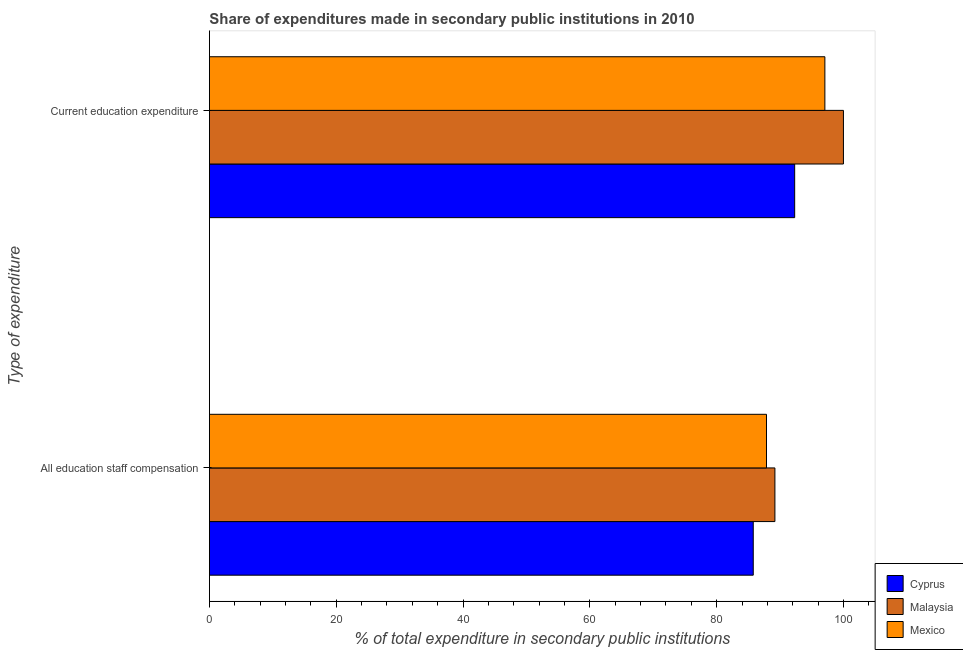Are the number of bars per tick equal to the number of legend labels?
Offer a terse response. Yes. Are the number of bars on each tick of the Y-axis equal?
Offer a very short reply. Yes. How many bars are there on the 1st tick from the top?
Ensure brevity in your answer.  3. What is the label of the 2nd group of bars from the top?
Provide a short and direct response. All education staff compensation. What is the expenditure in staff compensation in Malaysia?
Ensure brevity in your answer.  89.18. Across all countries, what is the maximum expenditure in education?
Make the answer very short. 99.99. Across all countries, what is the minimum expenditure in staff compensation?
Make the answer very short. 85.76. In which country was the expenditure in education maximum?
Offer a very short reply. Malaysia. In which country was the expenditure in education minimum?
Your answer should be very brief. Cyprus. What is the total expenditure in staff compensation in the graph?
Provide a succinct answer. 262.8. What is the difference between the expenditure in education in Cyprus and that in Malaysia?
Your response must be concise. -7.69. What is the difference between the expenditure in education in Cyprus and the expenditure in staff compensation in Mexico?
Offer a very short reply. 4.44. What is the average expenditure in education per country?
Give a very brief answer. 96.45. What is the difference between the expenditure in education and expenditure in staff compensation in Mexico?
Your response must be concise. 9.21. In how many countries, is the expenditure in staff compensation greater than 56 %?
Your response must be concise. 3. What is the ratio of the expenditure in education in Malaysia to that in Mexico?
Your answer should be compact. 1.03. In how many countries, is the expenditure in staff compensation greater than the average expenditure in staff compensation taken over all countries?
Your answer should be compact. 2. What does the 2nd bar from the top in All education staff compensation represents?
Make the answer very short. Malaysia. How many countries are there in the graph?
Your response must be concise. 3. Does the graph contain any zero values?
Your response must be concise. No. Where does the legend appear in the graph?
Offer a terse response. Bottom right. How many legend labels are there?
Your response must be concise. 3. What is the title of the graph?
Your response must be concise. Share of expenditures made in secondary public institutions in 2010. What is the label or title of the X-axis?
Ensure brevity in your answer.  % of total expenditure in secondary public institutions. What is the label or title of the Y-axis?
Your response must be concise. Type of expenditure. What is the % of total expenditure in secondary public institutions in Cyprus in All education staff compensation?
Offer a very short reply. 85.76. What is the % of total expenditure in secondary public institutions in Malaysia in All education staff compensation?
Make the answer very short. 89.18. What is the % of total expenditure in secondary public institutions of Mexico in All education staff compensation?
Give a very brief answer. 87.85. What is the % of total expenditure in secondary public institutions of Cyprus in Current education expenditure?
Make the answer very short. 92.3. What is the % of total expenditure in secondary public institutions in Malaysia in Current education expenditure?
Your response must be concise. 99.99. What is the % of total expenditure in secondary public institutions of Mexico in Current education expenditure?
Your answer should be compact. 97.06. Across all Type of expenditure, what is the maximum % of total expenditure in secondary public institutions of Cyprus?
Give a very brief answer. 92.3. Across all Type of expenditure, what is the maximum % of total expenditure in secondary public institutions in Malaysia?
Your response must be concise. 99.99. Across all Type of expenditure, what is the maximum % of total expenditure in secondary public institutions in Mexico?
Offer a very short reply. 97.06. Across all Type of expenditure, what is the minimum % of total expenditure in secondary public institutions in Cyprus?
Your response must be concise. 85.76. Across all Type of expenditure, what is the minimum % of total expenditure in secondary public institutions of Malaysia?
Your response must be concise. 89.18. Across all Type of expenditure, what is the minimum % of total expenditure in secondary public institutions in Mexico?
Make the answer very short. 87.85. What is the total % of total expenditure in secondary public institutions of Cyprus in the graph?
Make the answer very short. 178.06. What is the total % of total expenditure in secondary public institutions of Malaysia in the graph?
Provide a short and direct response. 189.17. What is the total % of total expenditure in secondary public institutions in Mexico in the graph?
Offer a terse response. 184.92. What is the difference between the % of total expenditure in secondary public institutions of Cyprus in All education staff compensation and that in Current education expenditure?
Provide a succinct answer. -6.53. What is the difference between the % of total expenditure in secondary public institutions in Malaysia in All education staff compensation and that in Current education expenditure?
Keep it short and to the point. -10.81. What is the difference between the % of total expenditure in secondary public institutions of Mexico in All education staff compensation and that in Current education expenditure?
Make the answer very short. -9.21. What is the difference between the % of total expenditure in secondary public institutions of Cyprus in All education staff compensation and the % of total expenditure in secondary public institutions of Malaysia in Current education expenditure?
Offer a terse response. -14.22. What is the difference between the % of total expenditure in secondary public institutions of Cyprus in All education staff compensation and the % of total expenditure in secondary public institutions of Mexico in Current education expenditure?
Offer a terse response. -11.3. What is the difference between the % of total expenditure in secondary public institutions in Malaysia in All education staff compensation and the % of total expenditure in secondary public institutions in Mexico in Current education expenditure?
Your response must be concise. -7.88. What is the average % of total expenditure in secondary public institutions of Cyprus per Type of expenditure?
Offer a terse response. 89.03. What is the average % of total expenditure in secondary public institutions of Malaysia per Type of expenditure?
Give a very brief answer. 94.58. What is the average % of total expenditure in secondary public institutions of Mexico per Type of expenditure?
Your answer should be very brief. 92.46. What is the difference between the % of total expenditure in secondary public institutions of Cyprus and % of total expenditure in secondary public institutions of Malaysia in All education staff compensation?
Provide a short and direct response. -3.42. What is the difference between the % of total expenditure in secondary public institutions of Cyprus and % of total expenditure in secondary public institutions of Mexico in All education staff compensation?
Give a very brief answer. -2.09. What is the difference between the % of total expenditure in secondary public institutions of Malaysia and % of total expenditure in secondary public institutions of Mexico in All education staff compensation?
Your response must be concise. 1.33. What is the difference between the % of total expenditure in secondary public institutions of Cyprus and % of total expenditure in secondary public institutions of Malaysia in Current education expenditure?
Your answer should be compact. -7.69. What is the difference between the % of total expenditure in secondary public institutions in Cyprus and % of total expenditure in secondary public institutions in Mexico in Current education expenditure?
Keep it short and to the point. -4.76. What is the difference between the % of total expenditure in secondary public institutions in Malaysia and % of total expenditure in secondary public institutions in Mexico in Current education expenditure?
Your response must be concise. 2.93. What is the ratio of the % of total expenditure in secondary public institutions of Cyprus in All education staff compensation to that in Current education expenditure?
Provide a succinct answer. 0.93. What is the ratio of the % of total expenditure in secondary public institutions of Malaysia in All education staff compensation to that in Current education expenditure?
Provide a short and direct response. 0.89. What is the ratio of the % of total expenditure in secondary public institutions of Mexico in All education staff compensation to that in Current education expenditure?
Provide a short and direct response. 0.91. What is the difference between the highest and the second highest % of total expenditure in secondary public institutions of Cyprus?
Provide a succinct answer. 6.53. What is the difference between the highest and the second highest % of total expenditure in secondary public institutions in Malaysia?
Offer a very short reply. 10.81. What is the difference between the highest and the second highest % of total expenditure in secondary public institutions in Mexico?
Provide a short and direct response. 9.21. What is the difference between the highest and the lowest % of total expenditure in secondary public institutions in Cyprus?
Offer a terse response. 6.53. What is the difference between the highest and the lowest % of total expenditure in secondary public institutions in Malaysia?
Provide a short and direct response. 10.81. What is the difference between the highest and the lowest % of total expenditure in secondary public institutions of Mexico?
Ensure brevity in your answer.  9.21. 